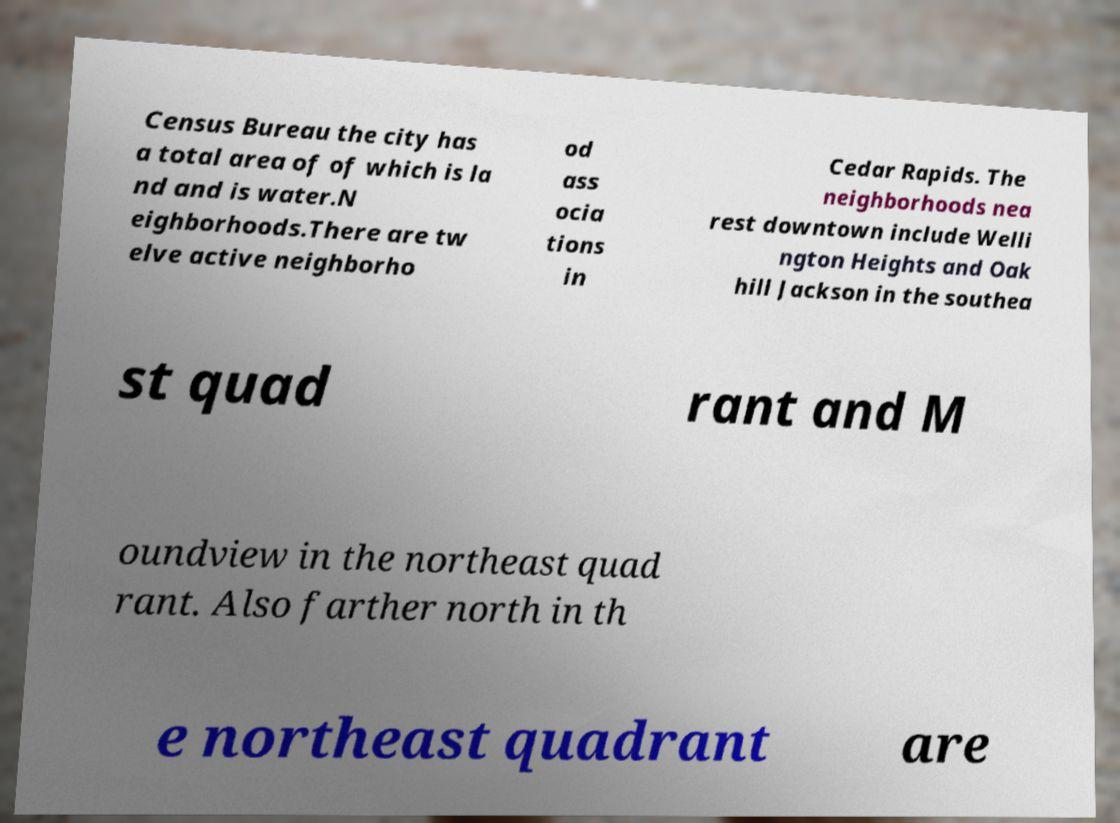I need the written content from this picture converted into text. Can you do that? Census Bureau the city has a total area of of which is la nd and is water.N eighborhoods.There are tw elve active neighborho od ass ocia tions in Cedar Rapids. The neighborhoods nea rest downtown include Welli ngton Heights and Oak hill Jackson in the southea st quad rant and M oundview in the northeast quad rant. Also farther north in th e northeast quadrant are 